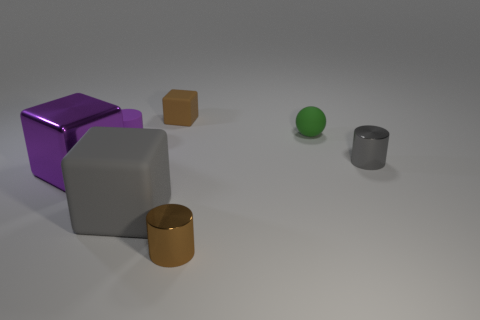Are there fewer metal cylinders that are behind the small green thing than large rubber blocks?
Your answer should be very brief. Yes. There is a rubber cube that is behind the small ball; what color is it?
Your response must be concise. Brown. What is the material of the block that is the same color as the matte cylinder?
Offer a very short reply. Metal. Are there any small brown objects that have the same shape as the large rubber thing?
Your answer should be very brief. Yes. How many gray metallic things are the same shape as the brown matte thing?
Your answer should be compact. 0. Is the color of the rubber cylinder the same as the metallic cube?
Ensure brevity in your answer.  Yes. Are there fewer big rubber cubes than tiny brown matte balls?
Your answer should be very brief. No. What material is the tiny cylinder that is to the right of the green sphere?
Provide a succinct answer. Metal. There is a gray block that is the same size as the purple shiny object; what is its material?
Your response must be concise. Rubber. What is the material of the gray object to the right of the gray object that is to the left of the tiny shiny cylinder that is in front of the small gray metal cylinder?
Your response must be concise. Metal. 